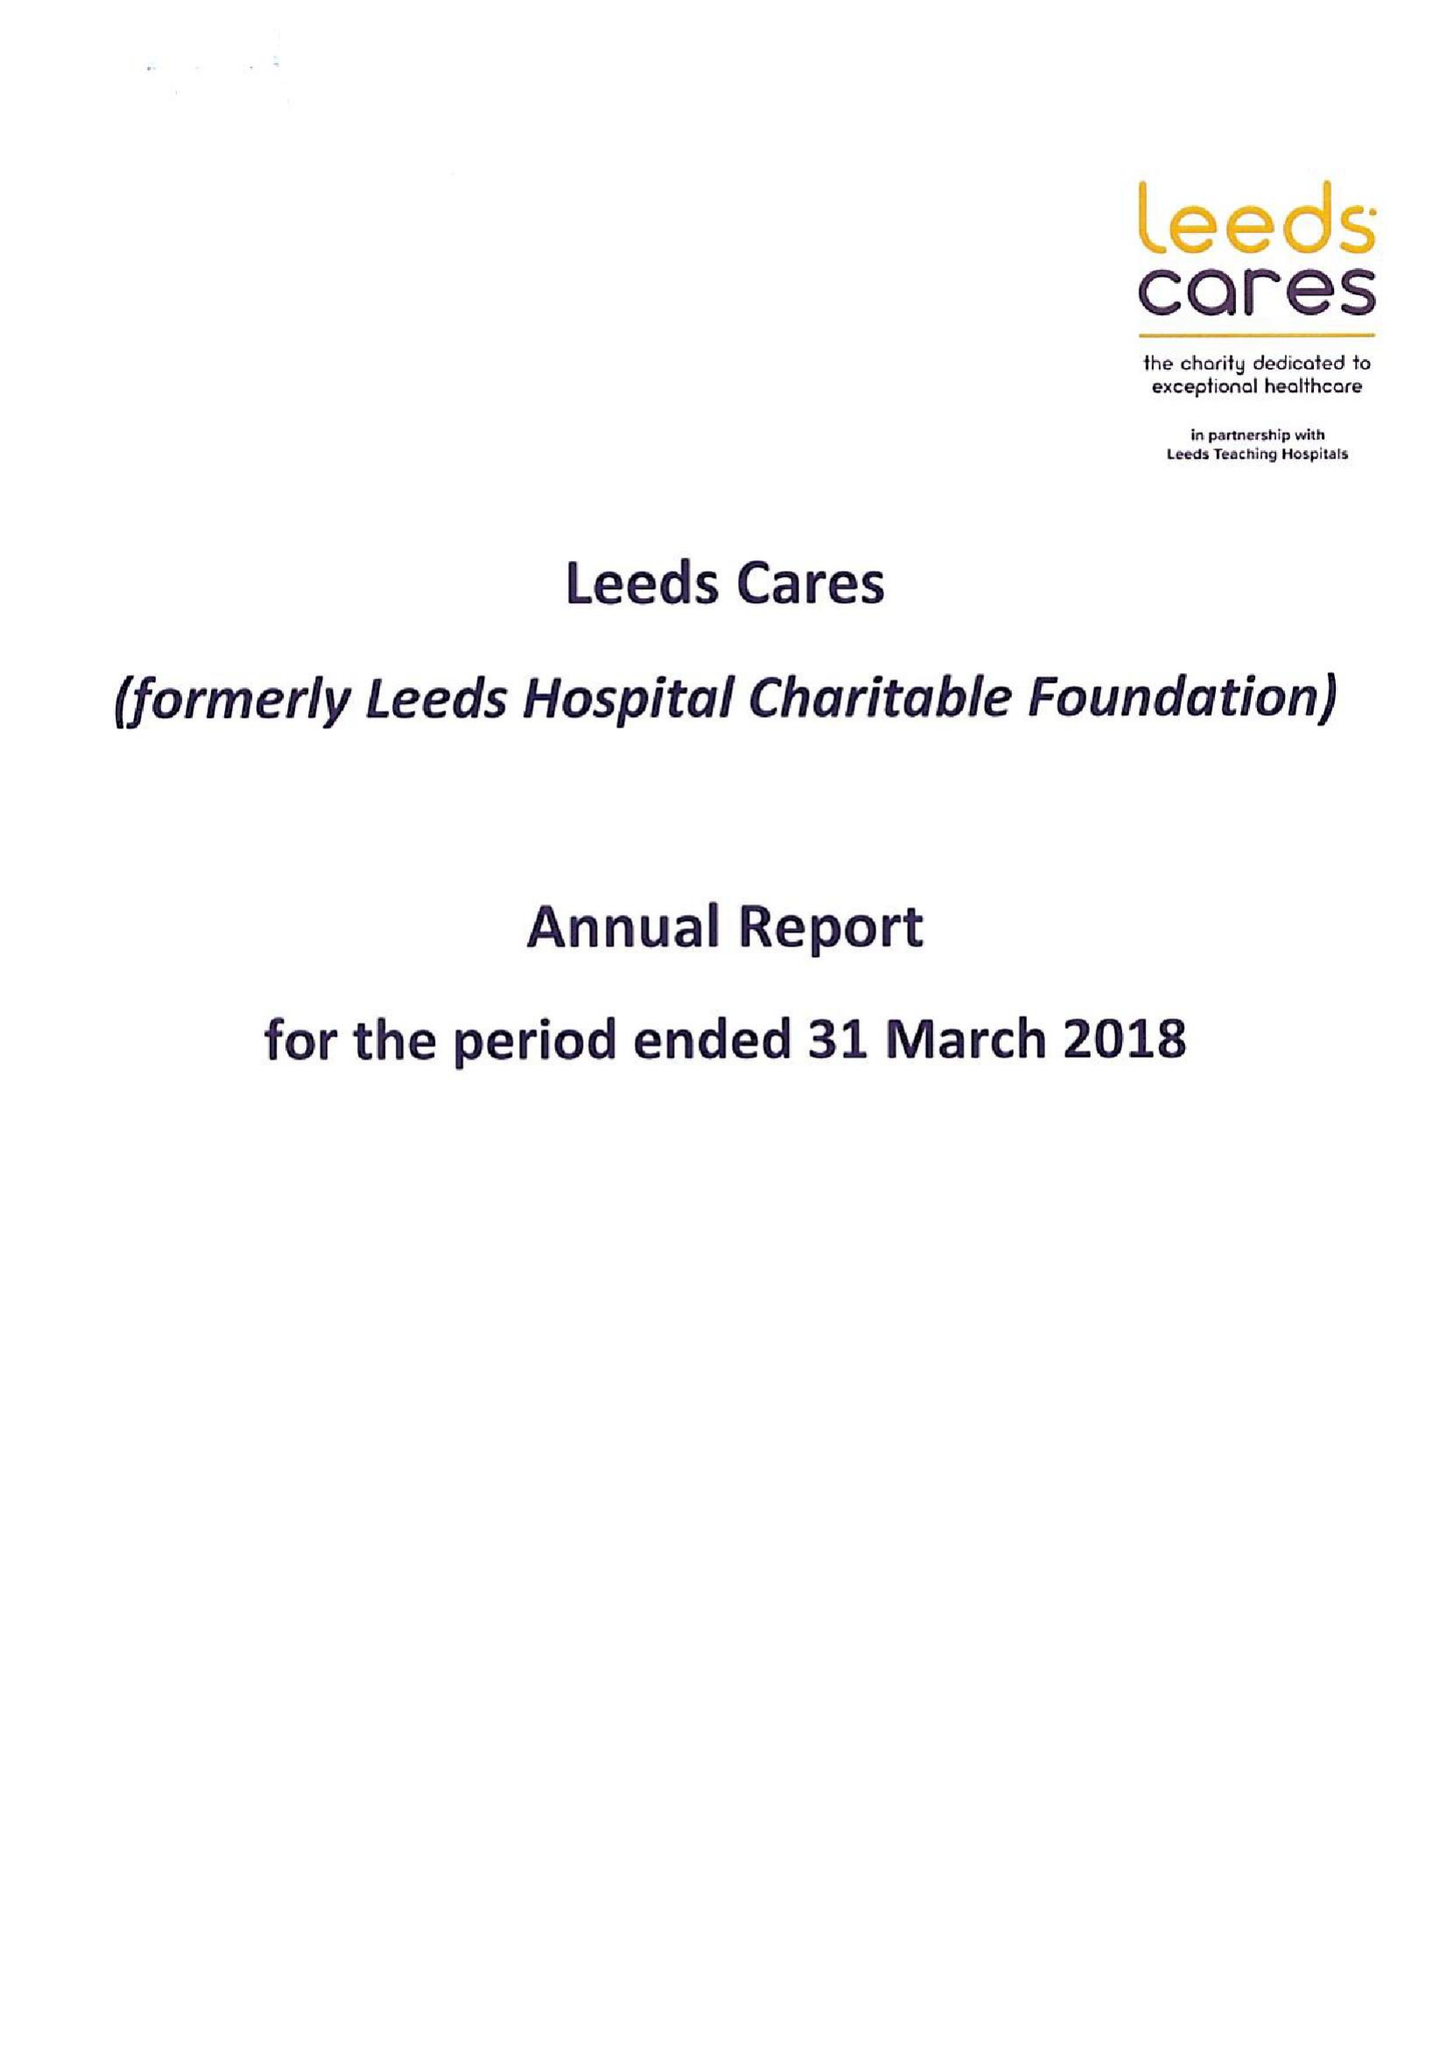What is the value for the address__post_town?
Answer the question using a single word or phrase. LEEDS 